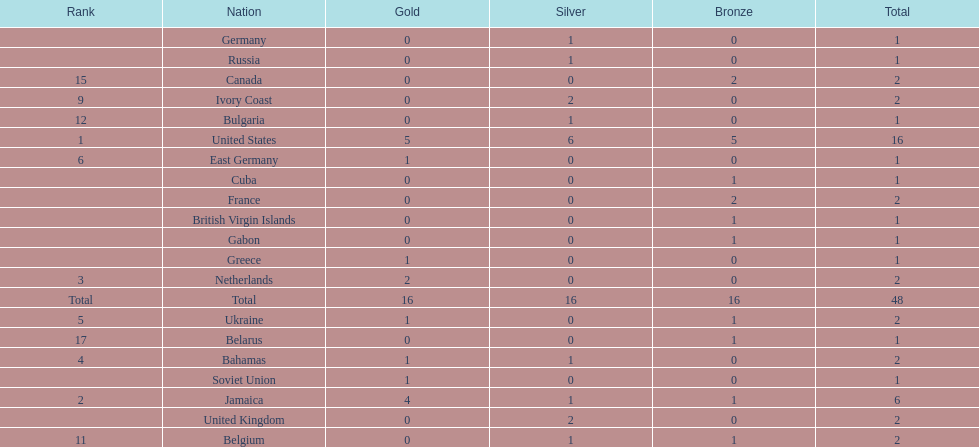What country won the most silver medals? United States. 